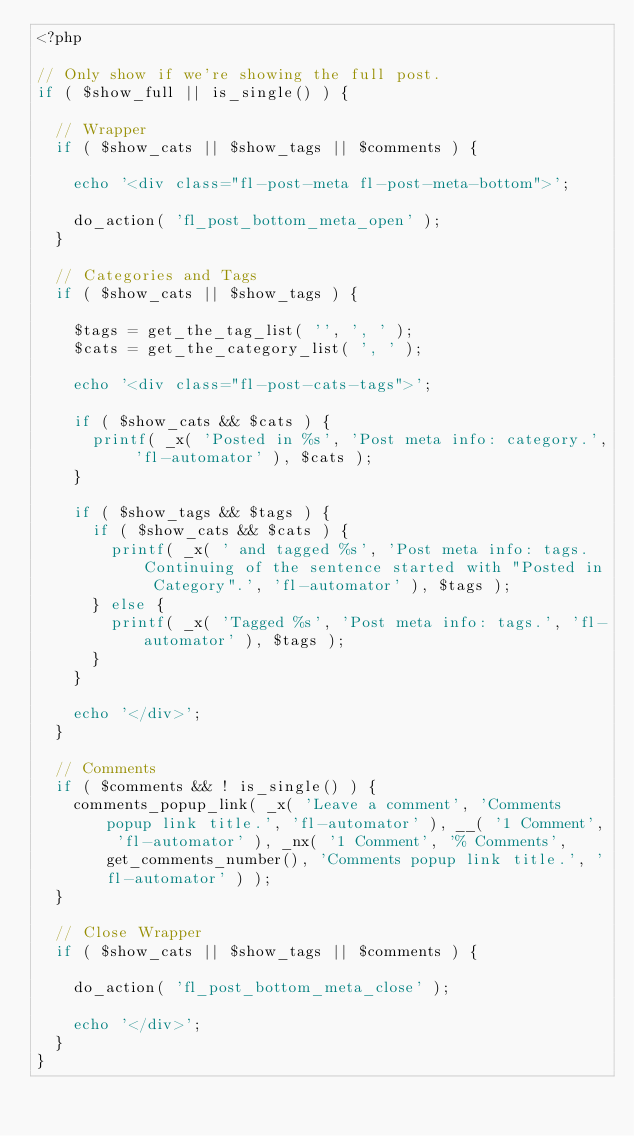Convert code to text. <code><loc_0><loc_0><loc_500><loc_500><_PHP_><?php

// Only show if we're showing the full post.
if ( $show_full || is_single() ) {

	// Wrapper
	if ( $show_cats || $show_tags || $comments ) {

		echo '<div class="fl-post-meta fl-post-meta-bottom">';

		do_action( 'fl_post_bottom_meta_open' );
	}

	// Categories and Tags
	if ( $show_cats || $show_tags ) {

		$tags = get_the_tag_list( '', ', ' );
		$cats = get_the_category_list( ', ' );

		echo '<div class="fl-post-cats-tags">';

		if ( $show_cats && $cats ) {
			printf( _x( 'Posted in %s', 'Post meta info: category.', 'fl-automator' ), $cats );
		}

		if ( $show_tags && $tags ) {
			if ( $show_cats && $cats ) {
				printf( _x( ' and tagged %s', 'Post meta info: tags. Continuing of the sentence started with "Posted in Category".', 'fl-automator' ), $tags );
			} else {
				printf( _x( 'Tagged %s', 'Post meta info: tags.', 'fl-automator' ), $tags );
			}
		}

		echo '</div>';
	}

	// Comments
	if ( $comments && ! is_single() ) {
		comments_popup_link( _x( 'Leave a comment', 'Comments popup link title.', 'fl-automator' ), __( '1 Comment', 'fl-automator' ), _nx( '1 Comment', '% Comments', get_comments_number(), 'Comments popup link title.', 'fl-automator' ) );
	}

	// Close Wrapper
	if ( $show_cats || $show_tags || $comments ) {

		do_action( 'fl_post_bottom_meta_close' );

		echo '</div>';
	}
}
</code> 